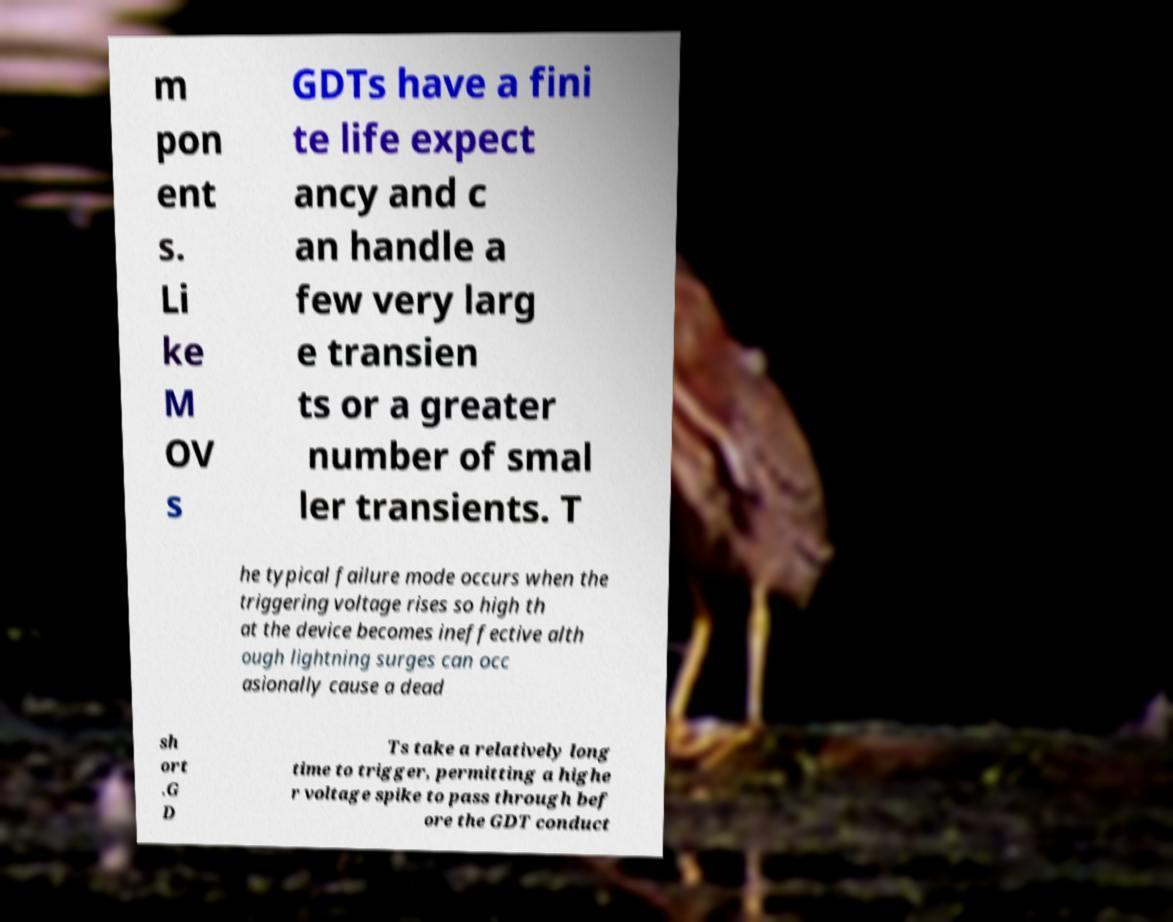There's text embedded in this image that I need extracted. Can you transcribe it verbatim? m pon ent s. Li ke M OV s GDTs have a fini te life expect ancy and c an handle a few very larg e transien ts or a greater number of smal ler transients. T he typical failure mode occurs when the triggering voltage rises so high th at the device becomes ineffective alth ough lightning surges can occ asionally cause a dead sh ort .G D Ts take a relatively long time to trigger, permitting a highe r voltage spike to pass through bef ore the GDT conduct 